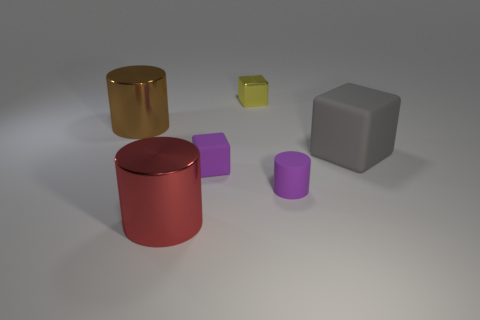What is the shape of the shiny thing that is both behind the purple rubber cylinder and to the left of the yellow metal cube?
Make the answer very short. Cylinder. How many small objects are either brown metal cylinders or metallic cylinders?
Offer a terse response. 0. Are there an equal number of tiny yellow cubes on the right side of the yellow thing and brown shiny things that are in front of the big brown cylinder?
Give a very brief answer. Yes. How many other objects are there of the same color as the matte cylinder?
Ensure brevity in your answer.  1. Is the number of large brown metal cylinders that are in front of the big gray rubber block the same as the number of purple things?
Your response must be concise. No. Is the size of the gray thing the same as the purple block?
Your answer should be very brief. No. There is a big object that is both behind the purple matte cylinder and left of the tiny yellow shiny cube; what material is it?
Offer a very short reply. Metal. What number of large red things are the same shape as the small metallic object?
Your answer should be very brief. 0. There is a small thing that is behind the large gray thing; what material is it?
Your response must be concise. Metal. Are there fewer gray things that are in front of the big red metallic object than tiny yellow matte cylinders?
Offer a very short reply. No. 